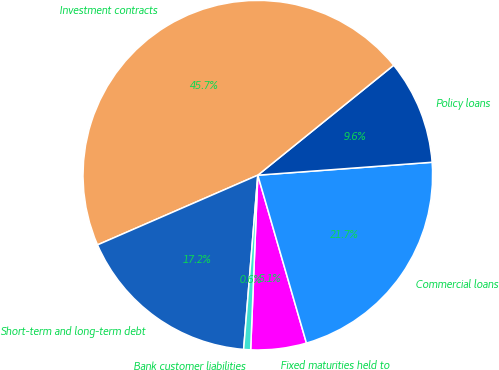Convert chart. <chart><loc_0><loc_0><loc_500><loc_500><pie_chart><fcel>Fixed maturities held to<fcel>Commercial loans<fcel>Policy loans<fcel>Investment contracts<fcel>Short-term and long-term debt<fcel>Bank customer liabilities<nl><fcel>5.14%<fcel>21.69%<fcel>9.65%<fcel>45.7%<fcel>17.18%<fcel>0.64%<nl></chart> 